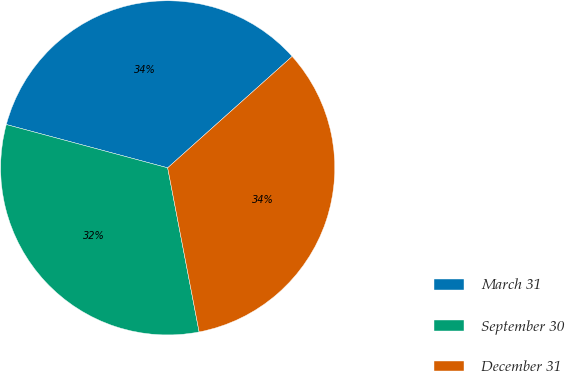Convert chart to OTSL. <chart><loc_0><loc_0><loc_500><loc_500><pie_chart><fcel>March 31<fcel>September 30<fcel>December 31<nl><fcel>34.21%<fcel>32.19%<fcel>33.61%<nl></chart> 